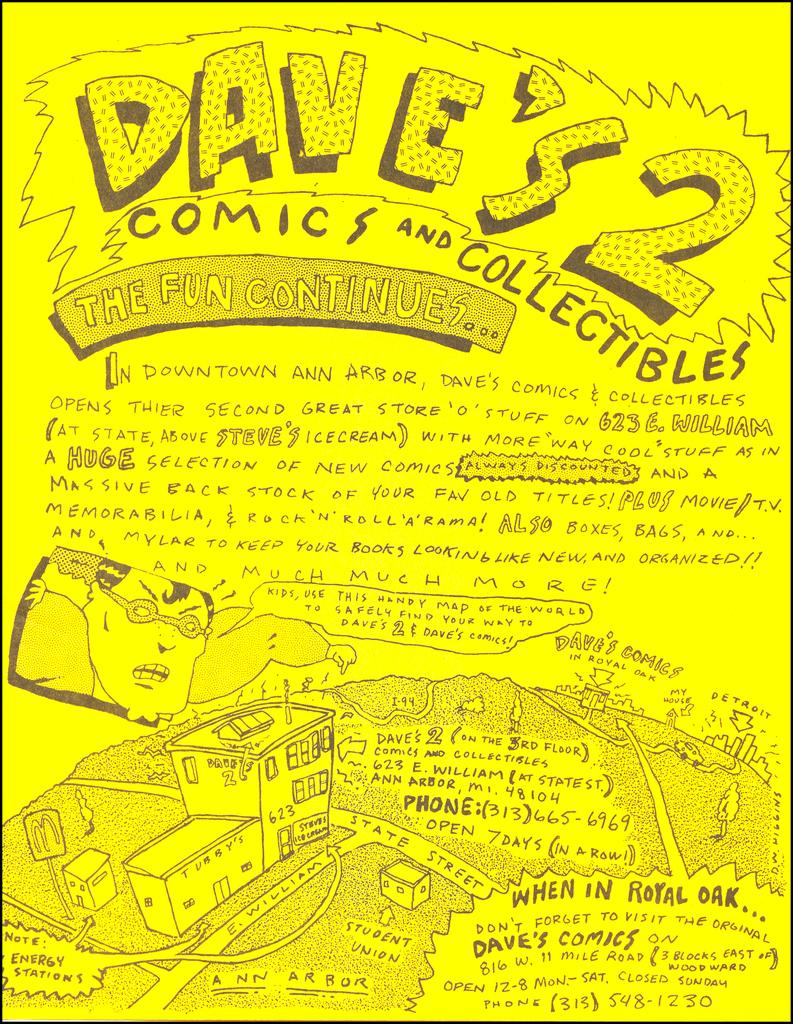What is featured on the poster in the image? The poster contains cartoons. What else can be found on the poster besides the cartoons? There is text on the poster. How many pigs are swimming in the river depicted on the poster? There are no pigs or rivers depicted on the poster; it features cartoons and text. 